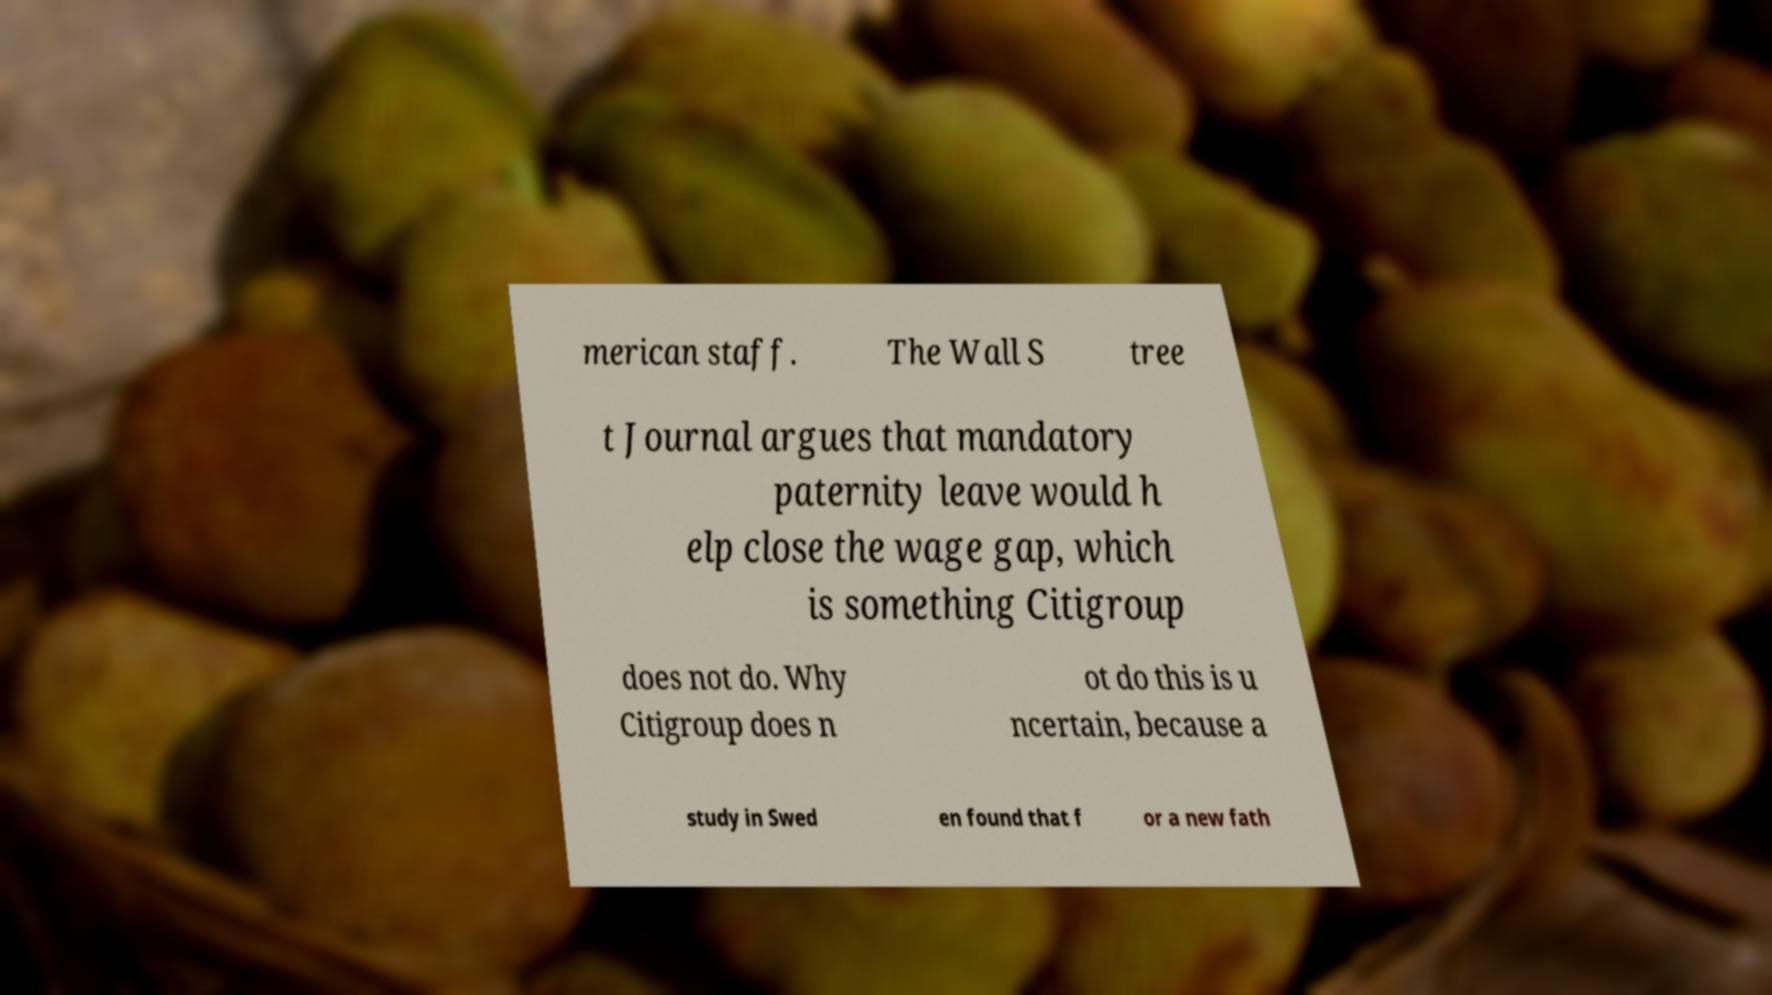Can you accurately transcribe the text from the provided image for me? merican staff. The Wall S tree t Journal argues that mandatory paternity leave would h elp close the wage gap, which is something Citigroup does not do. Why Citigroup does n ot do this is u ncertain, because a study in Swed en found that f or a new fath 